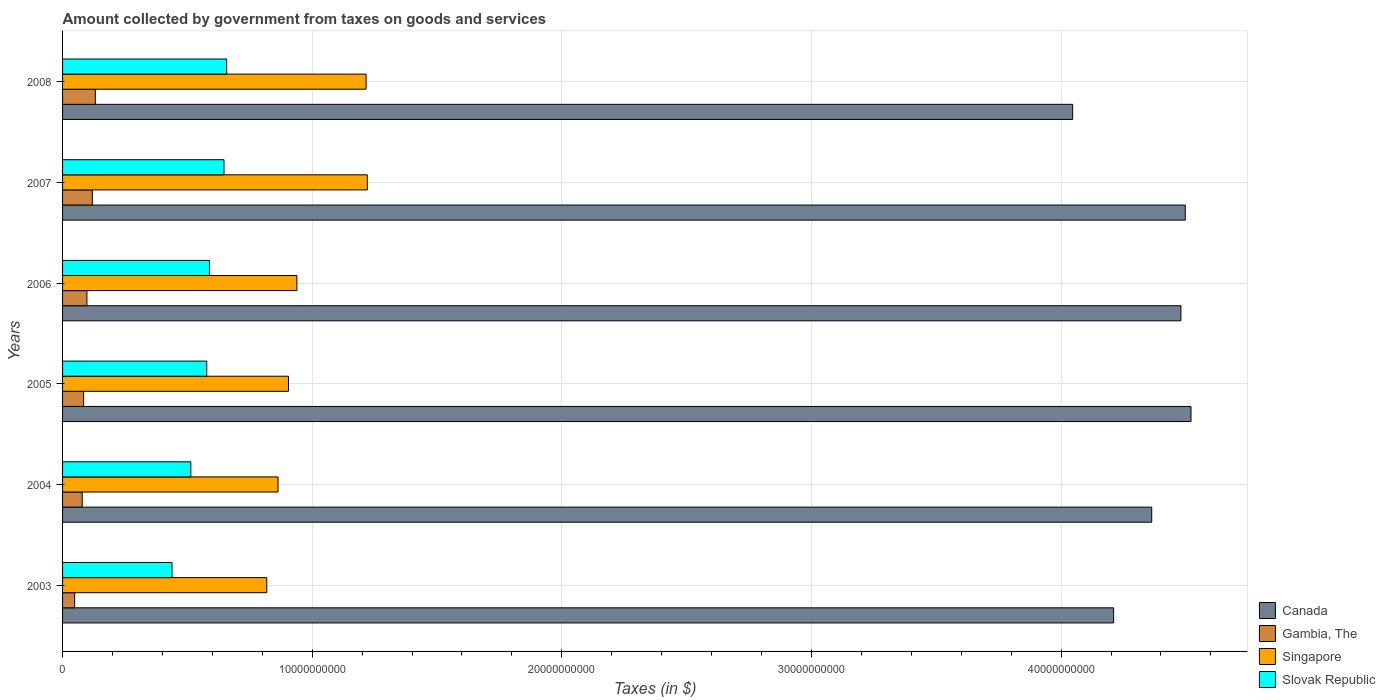How many groups of bars are there?
Provide a short and direct response. 6. Are the number of bars on each tick of the Y-axis equal?
Make the answer very short. Yes. How many bars are there on the 3rd tick from the top?
Keep it short and to the point. 4. What is the label of the 4th group of bars from the top?
Ensure brevity in your answer.  2005. In how many cases, is the number of bars for a given year not equal to the number of legend labels?
Offer a terse response. 0. What is the amount collected by government from taxes on goods and services in Slovak Republic in 2008?
Make the answer very short. 6.57e+09. Across all years, what is the maximum amount collected by government from taxes on goods and services in Gambia, The?
Keep it short and to the point. 1.31e+09. Across all years, what is the minimum amount collected by government from taxes on goods and services in Slovak Republic?
Your answer should be compact. 4.39e+09. In which year was the amount collected by government from taxes on goods and services in Canada maximum?
Provide a succinct answer. 2005. In which year was the amount collected by government from taxes on goods and services in Canada minimum?
Provide a short and direct response. 2008. What is the total amount collected by government from taxes on goods and services in Canada in the graph?
Your answer should be very brief. 2.61e+11. What is the difference between the amount collected by government from taxes on goods and services in Slovak Republic in 2007 and that in 2008?
Ensure brevity in your answer.  -1.08e+08. What is the difference between the amount collected by government from taxes on goods and services in Canada in 2005 and the amount collected by government from taxes on goods and services in Slovak Republic in 2003?
Keep it short and to the point. 4.08e+1. What is the average amount collected by government from taxes on goods and services in Slovak Republic per year?
Your answer should be very brief. 5.70e+09. In the year 2006, what is the difference between the amount collected by government from taxes on goods and services in Slovak Republic and amount collected by government from taxes on goods and services in Canada?
Give a very brief answer. -3.89e+1. What is the ratio of the amount collected by government from taxes on goods and services in Canada in 2006 to that in 2007?
Offer a very short reply. 1. Is the difference between the amount collected by government from taxes on goods and services in Slovak Republic in 2004 and 2008 greater than the difference between the amount collected by government from taxes on goods and services in Canada in 2004 and 2008?
Ensure brevity in your answer.  No. What is the difference between the highest and the second highest amount collected by government from taxes on goods and services in Singapore?
Keep it short and to the point. 5.00e+07. What is the difference between the highest and the lowest amount collected by government from taxes on goods and services in Slovak Republic?
Offer a terse response. 2.19e+09. What does the 4th bar from the top in 2003 represents?
Your response must be concise. Canada. What does the 4th bar from the bottom in 2006 represents?
Ensure brevity in your answer.  Slovak Republic. Are all the bars in the graph horizontal?
Offer a very short reply. Yes. How many years are there in the graph?
Your answer should be compact. 6. What is the difference between two consecutive major ticks on the X-axis?
Make the answer very short. 1.00e+1. Does the graph contain any zero values?
Your answer should be very brief. No. Does the graph contain grids?
Give a very brief answer. Yes. Where does the legend appear in the graph?
Keep it short and to the point. Bottom right. What is the title of the graph?
Ensure brevity in your answer.  Amount collected by government from taxes on goods and services. Does "Europe(developing only)" appear as one of the legend labels in the graph?
Keep it short and to the point. No. What is the label or title of the X-axis?
Keep it short and to the point. Taxes (in $). What is the label or title of the Y-axis?
Offer a very short reply. Years. What is the Taxes (in $) in Canada in 2003?
Ensure brevity in your answer.  4.21e+1. What is the Taxes (in $) of Gambia, The in 2003?
Provide a short and direct response. 4.84e+08. What is the Taxes (in $) in Singapore in 2003?
Your response must be concise. 8.18e+09. What is the Taxes (in $) of Slovak Republic in 2003?
Provide a short and direct response. 4.39e+09. What is the Taxes (in $) of Canada in 2004?
Ensure brevity in your answer.  4.36e+1. What is the Taxes (in $) of Gambia, The in 2004?
Make the answer very short. 7.87e+08. What is the Taxes (in $) of Singapore in 2004?
Your answer should be compact. 8.63e+09. What is the Taxes (in $) in Slovak Republic in 2004?
Keep it short and to the point. 5.14e+09. What is the Taxes (in $) in Canada in 2005?
Offer a very short reply. 4.52e+1. What is the Taxes (in $) in Gambia, The in 2005?
Give a very brief answer. 8.43e+08. What is the Taxes (in $) in Singapore in 2005?
Your answer should be compact. 9.05e+09. What is the Taxes (in $) in Slovak Republic in 2005?
Your answer should be very brief. 5.78e+09. What is the Taxes (in $) in Canada in 2006?
Provide a short and direct response. 4.48e+1. What is the Taxes (in $) of Gambia, The in 2006?
Make the answer very short. 9.76e+08. What is the Taxes (in $) of Singapore in 2006?
Provide a short and direct response. 9.39e+09. What is the Taxes (in $) in Slovak Republic in 2006?
Ensure brevity in your answer.  5.88e+09. What is the Taxes (in $) of Canada in 2007?
Keep it short and to the point. 4.50e+1. What is the Taxes (in $) of Gambia, The in 2007?
Offer a very short reply. 1.19e+09. What is the Taxes (in $) of Singapore in 2007?
Your answer should be compact. 1.22e+1. What is the Taxes (in $) of Slovak Republic in 2007?
Give a very brief answer. 6.47e+09. What is the Taxes (in $) in Canada in 2008?
Make the answer very short. 4.05e+1. What is the Taxes (in $) in Gambia, The in 2008?
Your answer should be very brief. 1.31e+09. What is the Taxes (in $) in Singapore in 2008?
Your response must be concise. 1.22e+1. What is the Taxes (in $) in Slovak Republic in 2008?
Provide a short and direct response. 6.57e+09. Across all years, what is the maximum Taxes (in $) of Canada?
Provide a short and direct response. 4.52e+1. Across all years, what is the maximum Taxes (in $) of Gambia, The?
Give a very brief answer. 1.31e+09. Across all years, what is the maximum Taxes (in $) in Singapore?
Your response must be concise. 1.22e+1. Across all years, what is the maximum Taxes (in $) in Slovak Republic?
Give a very brief answer. 6.57e+09. Across all years, what is the minimum Taxes (in $) of Canada?
Offer a terse response. 4.05e+1. Across all years, what is the minimum Taxes (in $) of Gambia, The?
Give a very brief answer. 4.84e+08. Across all years, what is the minimum Taxes (in $) of Singapore?
Give a very brief answer. 8.18e+09. Across all years, what is the minimum Taxes (in $) of Slovak Republic?
Keep it short and to the point. 4.39e+09. What is the total Taxes (in $) of Canada in the graph?
Ensure brevity in your answer.  2.61e+11. What is the total Taxes (in $) of Gambia, The in the graph?
Provide a short and direct response. 5.60e+09. What is the total Taxes (in $) of Singapore in the graph?
Your answer should be very brief. 5.96e+1. What is the total Taxes (in $) of Slovak Republic in the graph?
Provide a succinct answer. 3.42e+1. What is the difference between the Taxes (in $) of Canada in 2003 and that in 2004?
Your response must be concise. -1.53e+09. What is the difference between the Taxes (in $) in Gambia, The in 2003 and that in 2004?
Ensure brevity in your answer.  -3.03e+08. What is the difference between the Taxes (in $) of Singapore in 2003 and that in 2004?
Provide a succinct answer. -4.51e+08. What is the difference between the Taxes (in $) in Slovak Republic in 2003 and that in 2004?
Provide a short and direct response. -7.52e+08. What is the difference between the Taxes (in $) in Canada in 2003 and that in 2005?
Offer a very short reply. -3.10e+09. What is the difference between the Taxes (in $) of Gambia, The in 2003 and that in 2005?
Keep it short and to the point. -3.59e+08. What is the difference between the Taxes (in $) in Singapore in 2003 and that in 2005?
Your answer should be compact. -8.71e+08. What is the difference between the Taxes (in $) in Slovak Republic in 2003 and that in 2005?
Your response must be concise. -1.39e+09. What is the difference between the Taxes (in $) of Canada in 2003 and that in 2006?
Your answer should be very brief. -2.70e+09. What is the difference between the Taxes (in $) of Gambia, The in 2003 and that in 2006?
Keep it short and to the point. -4.91e+08. What is the difference between the Taxes (in $) in Singapore in 2003 and that in 2006?
Your answer should be very brief. -1.21e+09. What is the difference between the Taxes (in $) in Slovak Republic in 2003 and that in 2006?
Your response must be concise. -1.50e+09. What is the difference between the Taxes (in $) in Canada in 2003 and that in 2007?
Your answer should be compact. -2.87e+09. What is the difference between the Taxes (in $) in Gambia, The in 2003 and that in 2007?
Make the answer very short. -7.08e+08. What is the difference between the Taxes (in $) of Singapore in 2003 and that in 2007?
Offer a very short reply. -4.03e+09. What is the difference between the Taxes (in $) in Slovak Republic in 2003 and that in 2007?
Provide a short and direct response. -2.08e+09. What is the difference between the Taxes (in $) in Canada in 2003 and that in 2008?
Your answer should be compact. 1.64e+09. What is the difference between the Taxes (in $) of Gambia, The in 2003 and that in 2008?
Keep it short and to the point. -8.29e+08. What is the difference between the Taxes (in $) in Singapore in 2003 and that in 2008?
Make the answer very short. -3.98e+09. What is the difference between the Taxes (in $) of Slovak Republic in 2003 and that in 2008?
Your response must be concise. -2.19e+09. What is the difference between the Taxes (in $) in Canada in 2004 and that in 2005?
Your response must be concise. -1.57e+09. What is the difference between the Taxes (in $) of Gambia, The in 2004 and that in 2005?
Give a very brief answer. -5.66e+07. What is the difference between the Taxes (in $) of Singapore in 2004 and that in 2005?
Your answer should be very brief. -4.20e+08. What is the difference between the Taxes (in $) in Slovak Republic in 2004 and that in 2005?
Offer a terse response. -6.38e+08. What is the difference between the Taxes (in $) of Canada in 2004 and that in 2006?
Offer a very short reply. -1.17e+09. What is the difference between the Taxes (in $) of Gambia, The in 2004 and that in 2006?
Make the answer very short. -1.89e+08. What is the difference between the Taxes (in $) in Singapore in 2004 and that in 2006?
Keep it short and to the point. -7.56e+08. What is the difference between the Taxes (in $) of Slovak Republic in 2004 and that in 2006?
Keep it short and to the point. -7.46e+08. What is the difference between the Taxes (in $) in Canada in 2004 and that in 2007?
Ensure brevity in your answer.  -1.34e+09. What is the difference between the Taxes (in $) of Gambia, The in 2004 and that in 2007?
Provide a succinct answer. -4.06e+08. What is the difference between the Taxes (in $) of Singapore in 2004 and that in 2007?
Make the answer very short. -3.58e+09. What is the difference between the Taxes (in $) in Slovak Republic in 2004 and that in 2007?
Give a very brief answer. -1.33e+09. What is the difference between the Taxes (in $) of Canada in 2004 and that in 2008?
Provide a succinct answer. 3.17e+09. What is the difference between the Taxes (in $) in Gambia, The in 2004 and that in 2008?
Provide a succinct answer. -5.26e+08. What is the difference between the Taxes (in $) in Singapore in 2004 and that in 2008?
Offer a very short reply. -3.53e+09. What is the difference between the Taxes (in $) of Slovak Republic in 2004 and that in 2008?
Make the answer very short. -1.44e+09. What is the difference between the Taxes (in $) in Canada in 2005 and that in 2006?
Keep it short and to the point. 4.04e+08. What is the difference between the Taxes (in $) in Gambia, The in 2005 and that in 2006?
Your answer should be very brief. -1.32e+08. What is the difference between the Taxes (in $) of Singapore in 2005 and that in 2006?
Your response must be concise. -3.36e+08. What is the difference between the Taxes (in $) in Slovak Republic in 2005 and that in 2006?
Offer a very short reply. -1.08e+08. What is the difference between the Taxes (in $) of Canada in 2005 and that in 2007?
Ensure brevity in your answer.  2.28e+08. What is the difference between the Taxes (in $) of Gambia, The in 2005 and that in 2007?
Keep it short and to the point. -3.49e+08. What is the difference between the Taxes (in $) in Singapore in 2005 and that in 2007?
Ensure brevity in your answer.  -3.16e+09. What is the difference between the Taxes (in $) of Slovak Republic in 2005 and that in 2007?
Your answer should be very brief. -6.91e+08. What is the difference between the Taxes (in $) in Canada in 2005 and that in 2008?
Make the answer very short. 4.74e+09. What is the difference between the Taxes (in $) in Gambia, The in 2005 and that in 2008?
Provide a short and direct response. -4.70e+08. What is the difference between the Taxes (in $) in Singapore in 2005 and that in 2008?
Your response must be concise. -3.11e+09. What is the difference between the Taxes (in $) in Slovak Republic in 2005 and that in 2008?
Keep it short and to the point. -7.99e+08. What is the difference between the Taxes (in $) in Canada in 2006 and that in 2007?
Your response must be concise. -1.76e+08. What is the difference between the Taxes (in $) in Gambia, The in 2006 and that in 2007?
Your response must be concise. -2.17e+08. What is the difference between the Taxes (in $) in Singapore in 2006 and that in 2007?
Your answer should be compact. -2.82e+09. What is the difference between the Taxes (in $) in Slovak Republic in 2006 and that in 2007?
Give a very brief answer. -5.83e+08. What is the difference between the Taxes (in $) of Canada in 2006 and that in 2008?
Offer a terse response. 4.34e+09. What is the difference between the Taxes (in $) of Gambia, The in 2006 and that in 2008?
Your response must be concise. -3.38e+08. What is the difference between the Taxes (in $) of Singapore in 2006 and that in 2008?
Give a very brief answer. -2.77e+09. What is the difference between the Taxes (in $) of Slovak Republic in 2006 and that in 2008?
Keep it short and to the point. -6.91e+08. What is the difference between the Taxes (in $) in Canada in 2007 and that in 2008?
Provide a short and direct response. 4.51e+09. What is the difference between the Taxes (in $) of Gambia, The in 2007 and that in 2008?
Provide a succinct answer. -1.21e+08. What is the difference between the Taxes (in $) in Singapore in 2007 and that in 2008?
Provide a short and direct response. 5.00e+07. What is the difference between the Taxes (in $) in Slovak Republic in 2007 and that in 2008?
Give a very brief answer. -1.08e+08. What is the difference between the Taxes (in $) in Canada in 2003 and the Taxes (in $) in Gambia, The in 2004?
Provide a short and direct response. 4.13e+1. What is the difference between the Taxes (in $) in Canada in 2003 and the Taxes (in $) in Singapore in 2004?
Provide a short and direct response. 3.35e+1. What is the difference between the Taxes (in $) in Canada in 2003 and the Taxes (in $) in Slovak Republic in 2004?
Offer a very short reply. 3.70e+1. What is the difference between the Taxes (in $) of Gambia, The in 2003 and the Taxes (in $) of Singapore in 2004?
Your answer should be very brief. -8.15e+09. What is the difference between the Taxes (in $) of Gambia, The in 2003 and the Taxes (in $) of Slovak Republic in 2004?
Your answer should be very brief. -4.65e+09. What is the difference between the Taxes (in $) in Singapore in 2003 and the Taxes (in $) in Slovak Republic in 2004?
Provide a succinct answer. 3.04e+09. What is the difference between the Taxes (in $) in Canada in 2003 and the Taxes (in $) in Gambia, The in 2005?
Your answer should be compact. 4.13e+1. What is the difference between the Taxes (in $) in Canada in 2003 and the Taxes (in $) in Singapore in 2005?
Your response must be concise. 3.31e+1. What is the difference between the Taxes (in $) of Canada in 2003 and the Taxes (in $) of Slovak Republic in 2005?
Offer a very short reply. 3.63e+1. What is the difference between the Taxes (in $) in Gambia, The in 2003 and the Taxes (in $) in Singapore in 2005?
Provide a succinct answer. -8.57e+09. What is the difference between the Taxes (in $) in Gambia, The in 2003 and the Taxes (in $) in Slovak Republic in 2005?
Give a very brief answer. -5.29e+09. What is the difference between the Taxes (in $) in Singapore in 2003 and the Taxes (in $) in Slovak Republic in 2005?
Provide a succinct answer. 2.40e+09. What is the difference between the Taxes (in $) in Canada in 2003 and the Taxes (in $) in Gambia, The in 2006?
Offer a terse response. 4.11e+1. What is the difference between the Taxes (in $) in Canada in 2003 and the Taxes (in $) in Singapore in 2006?
Ensure brevity in your answer.  3.27e+1. What is the difference between the Taxes (in $) of Canada in 2003 and the Taxes (in $) of Slovak Republic in 2006?
Offer a terse response. 3.62e+1. What is the difference between the Taxes (in $) of Gambia, The in 2003 and the Taxes (in $) of Singapore in 2006?
Your answer should be compact. -8.90e+09. What is the difference between the Taxes (in $) in Gambia, The in 2003 and the Taxes (in $) in Slovak Republic in 2006?
Provide a succinct answer. -5.40e+09. What is the difference between the Taxes (in $) of Singapore in 2003 and the Taxes (in $) of Slovak Republic in 2006?
Keep it short and to the point. 2.30e+09. What is the difference between the Taxes (in $) of Canada in 2003 and the Taxes (in $) of Gambia, The in 2007?
Make the answer very short. 4.09e+1. What is the difference between the Taxes (in $) of Canada in 2003 and the Taxes (in $) of Singapore in 2007?
Ensure brevity in your answer.  2.99e+1. What is the difference between the Taxes (in $) of Canada in 2003 and the Taxes (in $) of Slovak Republic in 2007?
Your answer should be very brief. 3.56e+1. What is the difference between the Taxes (in $) of Gambia, The in 2003 and the Taxes (in $) of Singapore in 2007?
Offer a terse response. -1.17e+1. What is the difference between the Taxes (in $) in Gambia, The in 2003 and the Taxes (in $) in Slovak Republic in 2007?
Offer a terse response. -5.98e+09. What is the difference between the Taxes (in $) in Singapore in 2003 and the Taxes (in $) in Slovak Republic in 2007?
Your answer should be compact. 1.71e+09. What is the difference between the Taxes (in $) of Canada in 2003 and the Taxes (in $) of Gambia, The in 2008?
Offer a very short reply. 4.08e+1. What is the difference between the Taxes (in $) of Canada in 2003 and the Taxes (in $) of Singapore in 2008?
Make the answer very short. 2.99e+1. What is the difference between the Taxes (in $) of Canada in 2003 and the Taxes (in $) of Slovak Republic in 2008?
Provide a succinct answer. 3.55e+1. What is the difference between the Taxes (in $) of Gambia, The in 2003 and the Taxes (in $) of Singapore in 2008?
Make the answer very short. -1.17e+1. What is the difference between the Taxes (in $) in Gambia, The in 2003 and the Taxes (in $) in Slovak Republic in 2008?
Offer a terse response. -6.09e+09. What is the difference between the Taxes (in $) in Singapore in 2003 and the Taxes (in $) in Slovak Republic in 2008?
Provide a succinct answer. 1.60e+09. What is the difference between the Taxes (in $) of Canada in 2004 and the Taxes (in $) of Gambia, The in 2005?
Ensure brevity in your answer.  4.28e+1. What is the difference between the Taxes (in $) in Canada in 2004 and the Taxes (in $) in Singapore in 2005?
Your answer should be compact. 3.46e+1. What is the difference between the Taxes (in $) in Canada in 2004 and the Taxes (in $) in Slovak Republic in 2005?
Make the answer very short. 3.79e+1. What is the difference between the Taxes (in $) of Gambia, The in 2004 and the Taxes (in $) of Singapore in 2005?
Provide a succinct answer. -8.26e+09. What is the difference between the Taxes (in $) in Gambia, The in 2004 and the Taxes (in $) in Slovak Republic in 2005?
Keep it short and to the point. -4.99e+09. What is the difference between the Taxes (in $) in Singapore in 2004 and the Taxes (in $) in Slovak Republic in 2005?
Your response must be concise. 2.85e+09. What is the difference between the Taxes (in $) in Canada in 2004 and the Taxes (in $) in Gambia, The in 2006?
Your answer should be very brief. 4.27e+1. What is the difference between the Taxes (in $) in Canada in 2004 and the Taxes (in $) in Singapore in 2006?
Your answer should be compact. 3.42e+1. What is the difference between the Taxes (in $) in Canada in 2004 and the Taxes (in $) in Slovak Republic in 2006?
Ensure brevity in your answer.  3.77e+1. What is the difference between the Taxes (in $) in Gambia, The in 2004 and the Taxes (in $) in Singapore in 2006?
Keep it short and to the point. -8.60e+09. What is the difference between the Taxes (in $) in Gambia, The in 2004 and the Taxes (in $) in Slovak Republic in 2006?
Your answer should be very brief. -5.10e+09. What is the difference between the Taxes (in $) in Singapore in 2004 and the Taxes (in $) in Slovak Republic in 2006?
Offer a terse response. 2.75e+09. What is the difference between the Taxes (in $) of Canada in 2004 and the Taxes (in $) of Gambia, The in 2007?
Give a very brief answer. 4.24e+1. What is the difference between the Taxes (in $) of Canada in 2004 and the Taxes (in $) of Singapore in 2007?
Offer a terse response. 3.14e+1. What is the difference between the Taxes (in $) in Canada in 2004 and the Taxes (in $) in Slovak Republic in 2007?
Give a very brief answer. 3.72e+1. What is the difference between the Taxes (in $) in Gambia, The in 2004 and the Taxes (in $) in Singapore in 2007?
Provide a short and direct response. -1.14e+1. What is the difference between the Taxes (in $) of Gambia, The in 2004 and the Taxes (in $) of Slovak Republic in 2007?
Give a very brief answer. -5.68e+09. What is the difference between the Taxes (in $) of Singapore in 2004 and the Taxes (in $) of Slovak Republic in 2007?
Offer a very short reply. 2.16e+09. What is the difference between the Taxes (in $) of Canada in 2004 and the Taxes (in $) of Gambia, The in 2008?
Provide a succinct answer. 4.23e+1. What is the difference between the Taxes (in $) in Canada in 2004 and the Taxes (in $) in Singapore in 2008?
Make the answer very short. 3.15e+1. What is the difference between the Taxes (in $) of Canada in 2004 and the Taxes (in $) of Slovak Republic in 2008?
Ensure brevity in your answer.  3.71e+1. What is the difference between the Taxes (in $) of Gambia, The in 2004 and the Taxes (in $) of Singapore in 2008?
Give a very brief answer. -1.14e+1. What is the difference between the Taxes (in $) in Gambia, The in 2004 and the Taxes (in $) in Slovak Republic in 2008?
Offer a terse response. -5.79e+09. What is the difference between the Taxes (in $) of Singapore in 2004 and the Taxes (in $) of Slovak Republic in 2008?
Offer a very short reply. 2.06e+09. What is the difference between the Taxes (in $) in Canada in 2005 and the Taxes (in $) in Gambia, The in 2006?
Your response must be concise. 4.42e+1. What is the difference between the Taxes (in $) of Canada in 2005 and the Taxes (in $) of Singapore in 2006?
Your answer should be very brief. 3.58e+1. What is the difference between the Taxes (in $) of Canada in 2005 and the Taxes (in $) of Slovak Republic in 2006?
Offer a terse response. 3.93e+1. What is the difference between the Taxes (in $) in Gambia, The in 2005 and the Taxes (in $) in Singapore in 2006?
Offer a terse response. -8.54e+09. What is the difference between the Taxes (in $) of Gambia, The in 2005 and the Taxes (in $) of Slovak Republic in 2006?
Your response must be concise. -5.04e+09. What is the difference between the Taxes (in $) of Singapore in 2005 and the Taxes (in $) of Slovak Republic in 2006?
Ensure brevity in your answer.  3.17e+09. What is the difference between the Taxes (in $) of Canada in 2005 and the Taxes (in $) of Gambia, The in 2007?
Give a very brief answer. 4.40e+1. What is the difference between the Taxes (in $) of Canada in 2005 and the Taxes (in $) of Singapore in 2007?
Your answer should be very brief. 3.30e+1. What is the difference between the Taxes (in $) of Canada in 2005 and the Taxes (in $) of Slovak Republic in 2007?
Your answer should be very brief. 3.87e+1. What is the difference between the Taxes (in $) of Gambia, The in 2005 and the Taxes (in $) of Singapore in 2007?
Your answer should be compact. -1.14e+1. What is the difference between the Taxes (in $) of Gambia, The in 2005 and the Taxes (in $) of Slovak Republic in 2007?
Offer a very short reply. -5.62e+09. What is the difference between the Taxes (in $) of Singapore in 2005 and the Taxes (in $) of Slovak Republic in 2007?
Ensure brevity in your answer.  2.58e+09. What is the difference between the Taxes (in $) in Canada in 2005 and the Taxes (in $) in Gambia, The in 2008?
Ensure brevity in your answer.  4.39e+1. What is the difference between the Taxes (in $) of Canada in 2005 and the Taxes (in $) of Singapore in 2008?
Give a very brief answer. 3.30e+1. What is the difference between the Taxes (in $) of Canada in 2005 and the Taxes (in $) of Slovak Republic in 2008?
Ensure brevity in your answer.  3.86e+1. What is the difference between the Taxes (in $) of Gambia, The in 2005 and the Taxes (in $) of Singapore in 2008?
Offer a terse response. -1.13e+1. What is the difference between the Taxes (in $) of Gambia, The in 2005 and the Taxes (in $) of Slovak Republic in 2008?
Your answer should be very brief. -5.73e+09. What is the difference between the Taxes (in $) in Singapore in 2005 and the Taxes (in $) in Slovak Republic in 2008?
Make the answer very short. 2.48e+09. What is the difference between the Taxes (in $) in Canada in 2006 and the Taxes (in $) in Gambia, The in 2007?
Your response must be concise. 4.36e+1. What is the difference between the Taxes (in $) of Canada in 2006 and the Taxes (in $) of Singapore in 2007?
Offer a terse response. 3.26e+1. What is the difference between the Taxes (in $) of Canada in 2006 and the Taxes (in $) of Slovak Republic in 2007?
Ensure brevity in your answer.  3.83e+1. What is the difference between the Taxes (in $) of Gambia, The in 2006 and the Taxes (in $) of Singapore in 2007?
Keep it short and to the point. -1.12e+1. What is the difference between the Taxes (in $) in Gambia, The in 2006 and the Taxes (in $) in Slovak Republic in 2007?
Your response must be concise. -5.49e+09. What is the difference between the Taxes (in $) of Singapore in 2006 and the Taxes (in $) of Slovak Republic in 2007?
Make the answer very short. 2.92e+09. What is the difference between the Taxes (in $) of Canada in 2006 and the Taxes (in $) of Gambia, The in 2008?
Your response must be concise. 4.35e+1. What is the difference between the Taxes (in $) in Canada in 2006 and the Taxes (in $) in Singapore in 2008?
Offer a terse response. 3.26e+1. What is the difference between the Taxes (in $) of Canada in 2006 and the Taxes (in $) of Slovak Republic in 2008?
Ensure brevity in your answer.  3.82e+1. What is the difference between the Taxes (in $) of Gambia, The in 2006 and the Taxes (in $) of Singapore in 2008?
Your answer should be very brief. -1.12e+1. What is the difference between the Taxes (in $) of Gambia, The in 2006 and the Taxes (in $) of Slovak Republic in 2008?
Your answer should be very brief. -5.60e+09. What is the difference between the Taxes (in $) in Singapore in 2006 and the Taxes (in $) in Slovak Republic in 2008?
Provide a short and direct response. 2.81e+09. What is the difference between the Taxes (in $) of Canada in 2007 and the Taxes (in $) of Gambia, The in 2008?
Provide a succinct answer. 4.37e+1. What is the difference between the Taxes (in $) of Canada in 2007 and the Taxes (in $) of Singapore in 2008?
Ensure brevity in your answer.  3.28e+1. What is the difference between the Taxes (in $) of Canada in 2007 and the Taxes (in $) of Slovak Republic in 2008?
Your response must be concise. 3.84e+1. What is the difference between the Taxes (in $) of Gambia, The in 2007 and the Taxes (in $) of Singapore in 2008?
Provide a succinct answer. -1.10e+1. What is the difference between the Taxes (in $) in Gambia, The in 2007 and the Taxes (in $) in Slovak Republic in 2008?
Provide a succinct answer. -5.38e+09. What is the difference between the Taxes (in $) of Singapore in 2007 and the Taxes (in $) of Slovak Republic in 2008?
Provide a short and direct response. 5.63e+09. What is the average Taxes (in $) in Canada per year?
Provide a succinct answer. 4.35e+1. What is the average Taxes (in $) in Gambia, The per year?
Keep it short and to the point. 9.33e+08. What is the average Taxes (in $) in Singapore per year?
Provide a short and direct response. 9.94e+09. What is the average Taxes (in $) of Slovak Republic per year?
Provide a succinct answer. 5.70e+09. In the year 2003, what is the difference between the Taxes (in $) of Canada and Taxes (in $) of Gambia, The?
Your answer should be compact. 4.16e+1. In the year 2003, what is the difference between the Taxes (in $) in Canada and Taxes (in $) in Singapore?
Keep it short and to the point. 3.39e+1. In the year 2003, what is the difference between the Taxes (in $) of Canada and Taxes (in $) of Slovak Republic?
Offer a terse response. 3.77e+1. In the year 2003, what is the difference between the Taxes (in $) in Gambia, The and Taxes (in $) in Singapore?
Keep it short and to the point. -7.69e+09. In the year 2003, what is the difference between the Taxes (in $) in Gambia, The and Taxes (in $) in Slovak Republic?
Keep it short and to the point. -3.90e+09. In the year 2003, what is the difference between the Taxes (in $) of Singapore and Taxes (in $) of Slovak Republic?
Provide a short and direct response. 3.79e+09. In the year 2004, what is the difference between the Taxes (in $) in Canada and Taxes (in $) in Gambia, The?
Your answer should be compact. 4.28e+1. In the year 2004, what is the difference between the Taxes (in $) of Canada and Taxes (in $) of Singapore?
Your response must be concise. 3.50e+1. In the year 2004, what is the difference between the Taxes (in $) of Canada and Taxes (in $) of Slovak Republic?
Make the answer very short. 3.85e+1. In the year 2004, what is the difference between the Taxes (in $) in Gambia, The and Taxes (in $) in Singapore?
Offer a terse response. -7.84e+09. In the year 2004, what is the difference between the Taxes (in $) of Gambia, The and Taxes (in $) of Slovak Republic?
Your response must be concise. -4.35e+09. In the year 2004, what is the difference between the Taxes (in $) of Singapore and Taxes (in $) of Slovak Republic?
Your response must be concise. 3.49e+09. In the year 2005, what is the difference between the Taxes (in $) in Canada and Taxes (in $) in Gambia, The?
Your answer should be very brief. 4.44e+1. In the year 2005, what is the difference between the Taxes (in $) of Canada and Taxes (in $) of Singapore?
Offer a very short reply. 3.62e+1. In the year 2005, what is the difference between the Taxes (in $) in Canada and Taxes (in $) in Slovak Republic?
Your response must be concise. 3.94e+1. In the year 2005, what is the difference between the Taxes (in $) in Gambia, The and Taxes (in $) in Singapore?
Provide a succinct answer. -8.21e+09. In the year 2005, what is the difference between the Taxes (in $) in Gambia, The and Taxes (in $) in Slovak Republic?
Give a very brief answer. -4.93e+09. In the year 2005, what is the difference between the Taxes (in $) of Singapore and Taxes (in $) of Slovak Republic?
Provide a succinct answer. 3.27e+09. In the year 2006, what is the difference between the Taxes (in $) in Canada and Taxes (in $) in Gambia, The?
Keep it short and to the point. 4.38e+1. In the year 2006, what is the difference between the Taxes (in $) in Canada and Taxes (in $) in Singapore?
Your answer should be compact. 3.54e+1. In the year 2006, what is the difference between the Taxes (in $) of Canada and Taxes (in $) of Slovak Republic?
Ensure brevity in your answer.  3.89e+1. In the year 2006, what is the difference between the Taxes (in $) of Gambia, The and Taxes (in $) of Singapore?
Your answer should be compact. -8.41e+09. In the year 2006, what is the difference between the Taxes (in $) in Gambia, The and Taxes (in $) in Slovak Republic?
Your answer should be very brief. -4.91e+09. In the year 2006, what is the difference between the Taxes (in $) of Singapore and Taxes (in $) of Slovak Republic?
Give a very brief answer. 3.50e+09. In the year 2007, what is the difference between the Taxes (in $) in Canada and Taxes (in $) in Gambia, The?
Offer a very short reply. 4.38e+1. In the year 2007, what is the difference between the Taxes (in $) of Canada and Taxes (in $) of Singapore?
Provide a short and direct response. 3.28e+1. In the year 2007, what is the difference between the Taxes (in $) in Canada and Taxes (in $) in Slovak Republic?
Make the answer very short. 3.85e+1. In the year 2007, what is the difference between the Taxes (in $) in Gambia, The and Taxes (in $) in Singapore?
Your answer should be very brief. -1.10e+1. In the year 2007, what is the difference between the Taxes (in $) in Gambia, The and Taxes (in $) in Slovak Republic?
Keep it short and to the point. -5.27e+09. In the year 2007, what is the difference between the Taxes (in $) in Singapore and Taxes (in $) in Slovak Republic?
Keep it short and to the point. 5.74e+09. In the year 2008, what is the difference between the Taxes (in $) in Canada and Taxes (in $) in Gambia, The?
Ensure brevity in your answer.  3.91e+1. In the year 2008, what is the difference between the Taxes (in $) of Canada and Taxes (in $) of Singapore?
Offer a terse response. 2.83e+1. In the year 2008, what is the difference between the Taxes (in $) of Canada and Taxes (in $) of Slovak Republic?
Offer a very short reply. 3.39e+1. In the year 2008, what is the difference between the Taxes (in $) in Gambia, The and Taxes (in $) in Singapore?
Your answer should be compact. -1.08e+1. In the year 2008, what is the difference between the Taxes (in $) of Gambia, The and Taxes (in $) of Slovak Republic?
Give a very brief answer. -5.26e+09. In the year 2008, what is the difference between the Taxes (in $) of Singapore and Taxes (in $) of Slovak Republic?
Offer a very short reply. 5.58e+09. What is the ratio of the Taxes (in $) of Canada in 2003 to that in 2004?
Ensure brevity in your answer.  0.96. What is the ratio of the Taxes (in $) in Gambia, The in 2003 to that in 2004?
Provide a succinct answer. 0.62. What is the ratio of the Taxes (in $) of Singapore in 2003 to that in 2004?
Give a very brief answer. 0.95. What is the ratio of the Taxes (in $) in Slovak Republic in 2003 to that in 2004?
Keep it short and to the point. 0.85. What is the ratio of the Taxes (in $) of Canada in 2003 to that in 2005?
Provide a short and direct response. 0.93. What is the ratio of the Taxes (in $) in Gambia, The in 2003 to that in 2005?
Your answer should be very brief. 0.57. What is the ratio of the Taxes (in $) in Singapore in 2003 to that in 2005?
Offer a very short reply. 0.9. What is the ratio of the Taxes (in $) in Slovak Republic in 2003 to that in 2005?
Make the answer very short. 0.76. What is the ratio of the Taxes (in $) in Canada in 2003 to that in 2006?
Provide a succinct answer. 0.94. What is the ratio of the Taxes (in $) of Gambia, The in 2003 to that in 2006?
Provide a short and direct response. 0.5. What is the ratio of the Taxes (in $) in Singapore in 2003 to that in 2006?
Your response must be concise. 0.87. What is the ratio of the Taxes (in $) in Slovak Republic in 2003 to that in 2006?
Your answer should be very brief. 0.75. What is the ratio of the Taxes (in $) of Canada in 2003 to that in 2007?
Keep it short and to the point. 0.94. What is the ratio of the Taxes (in $) of Gambia, The in 2003 to that in 2007?
Offer a terse response. 0.41. What is the ratio of the Taxes (in $) of Singapore in 2003 to that in 2007?
Keep it short and to the point. 0.67. What is the ratio of the Taxes (in $) in Slovak Republic in 2003 to that in 2007?
Provide a succinct answer. 0.68. What is the ratio of the Taxes (in $) of Canada in 2003 to that in 2008?
Your answer should be very brief. 1.04. What is the ratio of the Taxes (in $) in Gambia, The in 2003 to that in 2008?
Offer a terse response. 0.37. What is the ratio of the Taxes (in $) in Singapore in 2003 to that in 2008?
Provide a succinct answer. 0.67. What is the ratio of the Taxes (in $) of Slovak Republic in 2003 to that in 2008?
Make the answer very short. 0.67. What is the ratio of the Taxes (in $) of Canada in 2004 to that in 2005?
Provide a short and direct response. 0.97. What is the ratio of the Taxes (in $) of Gambia, The in 2004 to that in 2005?
Make the answer very short. 0.93. What is the ratio of the Taxes (in $) of Singapore in 2004 to that in 2005?
Keep it short and to the point. 0.95. What is the ratio of the Taxes (in $) in Slovak Republic in 2004 to that in 2005?
Your answer should be very brief. 0.89. What is the ratio of the Taxes (in $) of Canada in 2004 to that in 2006?
Offer a very short reply. 0.97. What is the ratio of the Taxes (in $) of Gambia, The in 2004 to that in 2006?
Your answer should be compact. 0.81. What is the ratio of the Taxes (in $) of Singapore in 2004 to that in 2006?
Provide a short and direct response. 0.92. What is the ratio of the Taxes (in $) of Slovak Republic in 2004 to that in 2006?
Your response must be concise. 0.87. What is the ratio of the Taxes (in $) in Canada in 2004 to that in 2007?
Keep it short and to the point. 0.97. What is the ratio of the Taxes (in $) of Gambia, The in 2004 to that in 2007?
Your answer should be very brief. 0.66. What is the ratio of the Taxes (in $) of Singapore in 2004 to that in 2007?
Make the answer very short. 0.71. What is the ratio of the Taxes (in $) in Slovak Republic in 2004 to that in 2007?
Offer a terse response. 0.79. What is the ratio of the Taxes (in $) of Canada in 2004 to that in 2008?
Give a very brief answer. 1.08. What is the ratio of the Taxes (in $) of Gambia, The in 2004 to that in 2008?
Ensure brevity in your answer.  0.6. What is the ratio of the Taxes (in $) in Singapore in 2004 to that in 2008?
Keep it short and to the point. 0.71. What is the ratio of the Taxes (in $) of Slovak Republic in 2004 to that in 2008?
Provide a short and direct response. 0.78. What is the ratio of the Taxes (in $) in Canada in 2005 to that in 2006?
Your answer should be compact. 1.01. What is the ratio of the Taxes (in $) of Gambia, The in 2005 to that in 2006?
Offer a very short reply. 0.86. What is the ratio of the Taxes (in $) of Singapore in 2005 to that in 2006?
Give a very brief answer. 0.96. What is the ratio of the Taxes (in $) in Slovak Republic in 2005 to that in 2006?
Keep it short and to the point. 0.98. What is the ratio of the Taxes (in $) of Canada in 2005 to that in 2007?
Offer a terse response. 1.01. What is the ratio of the Taxes (in $) of Gambia, The in 2005 to that in 2007?
Your answer should be very brief. 0.71. What is the ratio of the Taxes (in $) in Singapore in 2005 to that in 2007?
Offer a very short reply. 0.74. What is the ratio of the Taxes (in $) of Slovak Republic in 2005 to that in 2007?
Provide a succinct answer. 0.89. What is the ratio of the Taxes (in $) of Canada in 2005 to that in 2008?
Make the answer very short. 1.12. What is the ratio of the Taxes (in $) in Gambia, The in 2005 to that in 2008?
Provide a short and direct response. 0.64. What is the ratio of the Taxes (in $) of Singapore in 2005 to that in 2008?
Ensure brevity in your answer.  0.74. What is the ratio of the Taxes (in $) of Slovak Republic in 2005 to that in 2008?
Your answer should be compact. 0.88. What is the ratio of the Taxes (in $) in Canada in 2006 to that in 2007?
Your answer should be compact. 1. What is the ratio of the Taxes (in $) of Gambia, The in 2006 to that in 2007?
Make the answer very short. 0.82. What is the ratio of the Taxes (in $) of Singapore in 2006 to that in 2007?
Your answer should be compact. 0.77. What is the ratio of the Taxes (in $) of Slovak Republic in 2006 to that in 2007?
Give a very brief answer. 0.91. What is the ratio of the Taxes (in $) in Canada in 2006 to that in 2008?
Offer a very short reply. 1.11. What is the ratio of the Taxes (in $) of Gambia, The in 2006 to that in 2008?
Give a very brief answer. 0.74. What is the ratio of the Taxes (in $) in Singapore in 2006 to that in 2008?
Your answer should be very brief. 0.77. What is the ratio of the Taxes (in $) in Slovak Republic in 2006 to that in 2008?
Offer a terse response. 0.89. What is the ratio of the Taxes (in $) of Canada in 2007 to that in 2008?
Provide a short and direct response. 1.11. What is the ratio of the Taxes (in $) of Gambia, The in 2007 to that in 2008?
Offer a terse response. 0.91. What is the ratio of the Taxes (in $) of Singapore in 2007 to that in 2008?
Make the answer very short. 1. What is the ratio of the Taxes (in $) in Slovak Republic in 2007 to that in 2008?
Your answer should be very brief. 0.98. What is the difference between the highest and the second highest Taxes (in $) of Canada?
Provide a succinct answer. 2.28e+08. What is the difference between the highest and the second highest Taxes (in $) of Gambia, The?
Make the answer very short. 1.21e+08. What is the difference between the highest and the second highest Taxes (in $) in Slovak Republic?
Your answer should be compact. 1.08e+08. What is the difference between the highest and the lowest Taxes (in $) of Canada?
Your answer should be compact. 4.74e+09. What is the difference between the highest and the lowest Taxes (in $) of Gambia, The?
Your answer should be compact. 8.29e+08. What is the difference between the highest and the lowest Taxes (in $) in Singapore?
Your answer should be compact. 4.03e+09. What is the difference between the highest and the lowest Taxes (in $) in Slovak Republic?
Offer a terse response. 2.19e+09. 